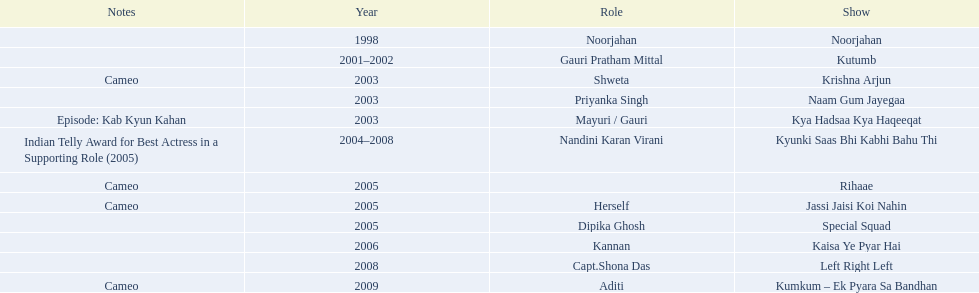What role  was played for the latest show Cameo. Who played the last cameo before ? Jassi Jaisi Koi Nahin. 